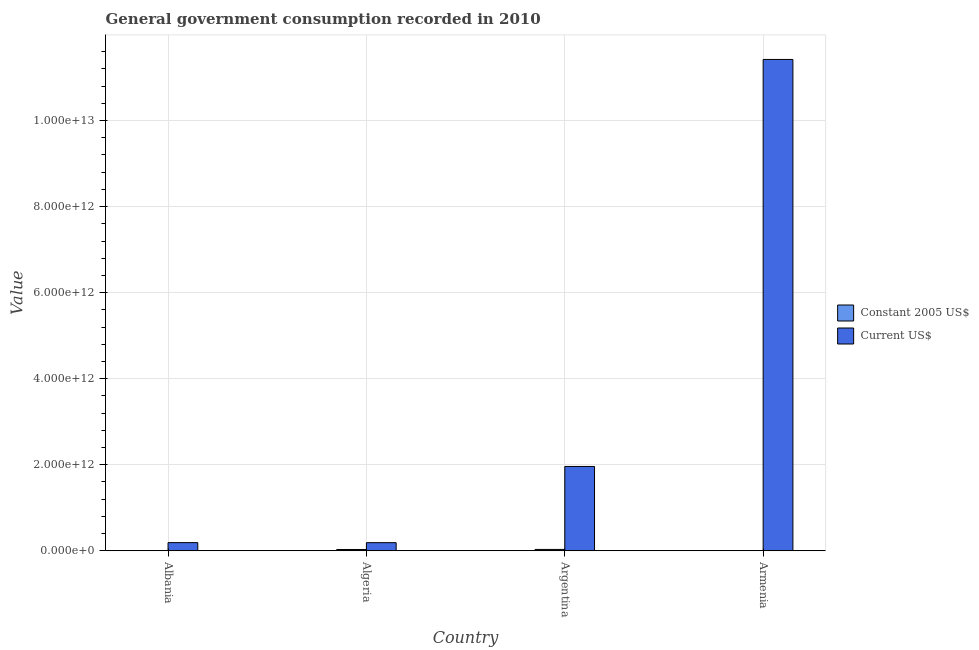How many different coloured bars are there?
Keep it short and to the point. 2. How many bars are there on the 4th tick from the left?
Offer a terse response. 2. How many bars are there on the 3rd tick from the right?
Keep it short and to the point. 2. What is the label of the 1st group of bars from the left?
Ensure brevity in your answer.  Albania. In how many cases, is the number of bars for a given country not equal to the number of legend labels?
Your answer should be very brief. 0. What is the value consumed in constant 2005 us$ in Armenia?
Your answer should be very brief. 6.25e+08. Across all countries, what is the maximum value consumed in current us$?
Offer a very short reply. 1.14e+13. Across all countries, what is the minimum value consumed in current us$?
Your response must be concise. 1.89e+11. In which country was the value consumed in constant 2005 us$ minimum?
Provide a short and direct response. Armenia. What is the total value consumed in constant 2005 us$ in the graph?
Make the answer very short. 6.28e+1. What is the difference between the value consumed in current us$ in Albania and that in Algeria?
Your answer should be compact. 8.57e+08. What is the difference between the value consumed in current us$ in Algeria and the value consumed in constant 2005 us$ in Armenia?
Your answer should be very brief. 1.88e+11. What is the average value consumed in constant 2005 us$ per country?
Keep it short and to the point. 1.57e+1. What is the difference between the value consumed in current us$ and value consumed in constant 2005 us$ in Albania?
Give a very brief answer. 1.88e+11. What is the ratio of the value consumed in current us$ in Albania to that in Algeria?
Offer a very short reply. 1. Is the value consumed in current us$ in Albania less than that in Armenia?
Your response must be concise. Yes. Is the difference between the value consumed in constant 2005 us$ in Albania and Argentina greater than the difference between the value consumed in current us$ in Albania and Argentina?
Keep it short and to the point. Yes. What is the difference between the highest and the second highest value consumed in current us$?
Your response must be concise. 9.46e+12. What is the difference between the highest and the lowest value consumed in current us$?
Make the answer very short. 1.12e+13. Is the sum of the value consumed in current us$ in Argentina and Armenia greater than the maximum value consumed in constant 2005 us$ across all countries?
Provide a short and direct response. Yes. What does the 2nd bar from the left in Armenia represents?
Your response must be concise. Current US$. What does the 1st bar from the right in Argentina represents?
Give a very brief answer. Current US$. How many bars are there?
Your response must be concise. 8. What is the difference between two consecutive major ticks on the Y-axis?
Ensure brevity in your answer.  2.00e+12. Are the values on the major ticks of Y-axis written in scientific E-notation?
Your answer should be compact. Yes. Does the graph contain grids?
Give a very brief answer. Yes. Where does the legend appear in the graph?
Your answer should be very brief. Center right. What is the title of the graph?
Make the answer very short. General government consumption recorded in 2010. What is the label or title of the Y-axis?
Make the answer very short. Value. What is the Value in Constant 2005 US$ in Albania?
Offer a terse response. 1.04e+09. What is the Value in Current US$ in Albania?
Your response must be concise. 1.89e+11. What is the Value in Constant 2005 US$ in Algeria?
Offer a terse response. 2.99e+1. What is the Value of Current US$ in Algeria?
Offer a terse response. 1.89e+11. What is the Value of Constant 2005 US$ in Argentina?
Your response must be concise. 3.12e+1. What is the Value of Current US$ in Argentina?
Provide a succinct answer. 1.96e+12. What is the Value in Constant 2005 US$ in Armenia?
Provide a short and direct response. 6.25e+08. What is the Value of Current US$ in Armenia?
Offer a very short reply. 1.14e+13. Across all countries, what is the maximum Value of Constant 2005 US$?
Provide a short and direct response. 3.12e+1. Across all countries, what is the maximum Value in Current US$?
Provide a short and direct response. 1.14e+13. Across all countries, what is the minimum Value of Constant 2005 US$?
Make the answer very short. 6.25e+08. Across all countries, what is the minimum Value in Current US$?
Provide a succinct answer. 1.89e+11. What is the total Value in Constant 2005 US$ in the graph?
Keep it short and to the point. 6.28e+1. What is the total Value of Current US$ in the graph?
Your answer should be compact. 1.38e+13. What is the difference between the Value of Constant 2005 US$ in Albania and that in Algeria?
Your answer should be compact. -2.89e+1. What is the difference between the Value in Current US$ in Albania and that in Algeria?
Provide a succinct answer. 8.57e+08. What is the difference between the Value in Constant 2005 US$ in Albania and that in Argentina?
Make the answer very short. -3.02e+1. What is the difference between the Value in Current US$ in Albania and that in Argentina?
Your answer should be compact. -1.77e+12. What is the difference between the Value in Constant 2005 US$ in Albania and that in Armenia?
Make the answer very short. 4.17e+08. What is the difference between the Value of Current US$ in Albania and that in Armenia?
Offer a terse response. -1.12e+13. What is the difference between the Value in Constant 2005 US$ in Algeria and that in Argentina?
Provide a succinct answer. -1.29e+09. What is the difference between the Value of Current US$ in Algeria and that in Argentina?
Make the answer very short. -1.77e+12. What is the difference between the Value of Constant 2005 US$ in Algeria and that in Armenia?
Make the answer very short. 2.93e+1. What is the difference between the Value in Current US$ in Algeria and that in Armenia?
Offer a very short reply. -1.12e+13. What is the difference between the Value of Constant 2005 US$ in Argentina and that in Armenia?
Make the answer very short. 3.06e+1. What is the difference between the Value in Current US$ in Argentina and that in Armenia?
Offer a very short reply. -9.46e+12. What is the difference between the Value in Constant 2005 US$ in Albania and the Value in Current US$ in Algeria?
Offer a terse response. -1.88e+11. What is the difference between the Value in Constant 2005 US$ in Albania and the Value in Current US$ in Argentina?
Your response must be concise. -1.96e+12. What is the difference between the Value of Constant 2005 US$ in Albania and the Value of Current US$ in Armenia?
Make the answer very short. -1.14e+13. What is the difference between the Value of Constant 2005 US$ in Algeria and the Value of Current US$ in Argentina?
Offer a very short reply. -1.93e+12. What is the difference between the Value of Constant 2005 US$ in Algeria and the Value of Current US$ in Armenia?
Give a very brief answer. -1.14e+13. What is the difference between the Value in Constant 2005 US$ in Argentina and the Value in Current US$ in Armenia?
Ensure brevity in your answer.  -1.14e+13. What is the average Value in Constant 2005 US$ per country?
Make the answer very short. 1.57e+1. What is the average Value of Current US$ per country?
Your response must be concise. 3.44e+12. What is the difference between the Value in Constant 2005 US$ and Value in Current US$ in Albania?
Give a very brief answer. -1.88e+11. What is the difference between the Value in Constant 2005 US$ and Value in Current US$ in Algeria?
Provide a succinct answer. -1.59e+11. What is the difference between the Value in Constant 2005 US$ and Value in Current US$ in Argentina?
Your response must be concise. -1.93e+12. What is the difference between the Value in Constant 2005 US$ and Value in Current US$ in Armenia?
Offer a very short reply. -1.14e+13. What is the ratio of the Value of Constant 2005 US$ in Albania to that in Algeria?
Ensure brevity in your answer.  0.03. What is the ratio of the Value of Current US$ in Albania to that in Algeria?
Your response must be concise. 1. What is the ratio of the Value in Constant 2005 US$ in Albania to that in Argentina?
Make the answer very short. 0.03. What is the ratio of the Value in Current US$ in Albania to that in Argentina?
Offer a terse response. 0.1. What is the ratio of the Value in Constant 2005 US$ in Albania to that in Armenia?
Keep it short and to the point. 1.67. What is the ratio of the Value of Current US$ in Albania to that in Armenia?
Offer a very short reply. 0.02. What is the ratio of the Value in Constant 2005 US$ in Algeria to that in Argentina?
Give a very brief answer. 0.96. What is the ratio of the Value in Current US$ in Algeria to that in Argentina?
Ensure brevity in your answer.  0.1. What is the ratio of the Value of Constant 2005 US$ in Algeria to that in Armenia?
Your answer should be compact. 47.86. What is the ratio of the Value in Current US$ in Algeria to that in Armenia?
Your answer should be compact. 0.02. What is the ratio of the Value in Constant 2005 US$ in Argentina to that in Armenia?
Your answer should be very brief. 49.93. What is the ratio of the Value in Current US$ in Argentina to that in Armenia?
Provide a succinct answer. 0.17. What is the difference between the highest and the second highest Value of Constant 2005 US$?
Ensure brevity in your answer.  1.29e+09. What is the difference between the highest and the second highest Value of Current US$?
Make the answer very short. 9.46e+12. What is the difference between the highest and the lowest Value in Constant 2005 US$?
Give a very brief answer. 3.06e+1. What is the difference between the highest and the lowest Value in Current US$?
Provide a short and direct response. 1.12e+13. 